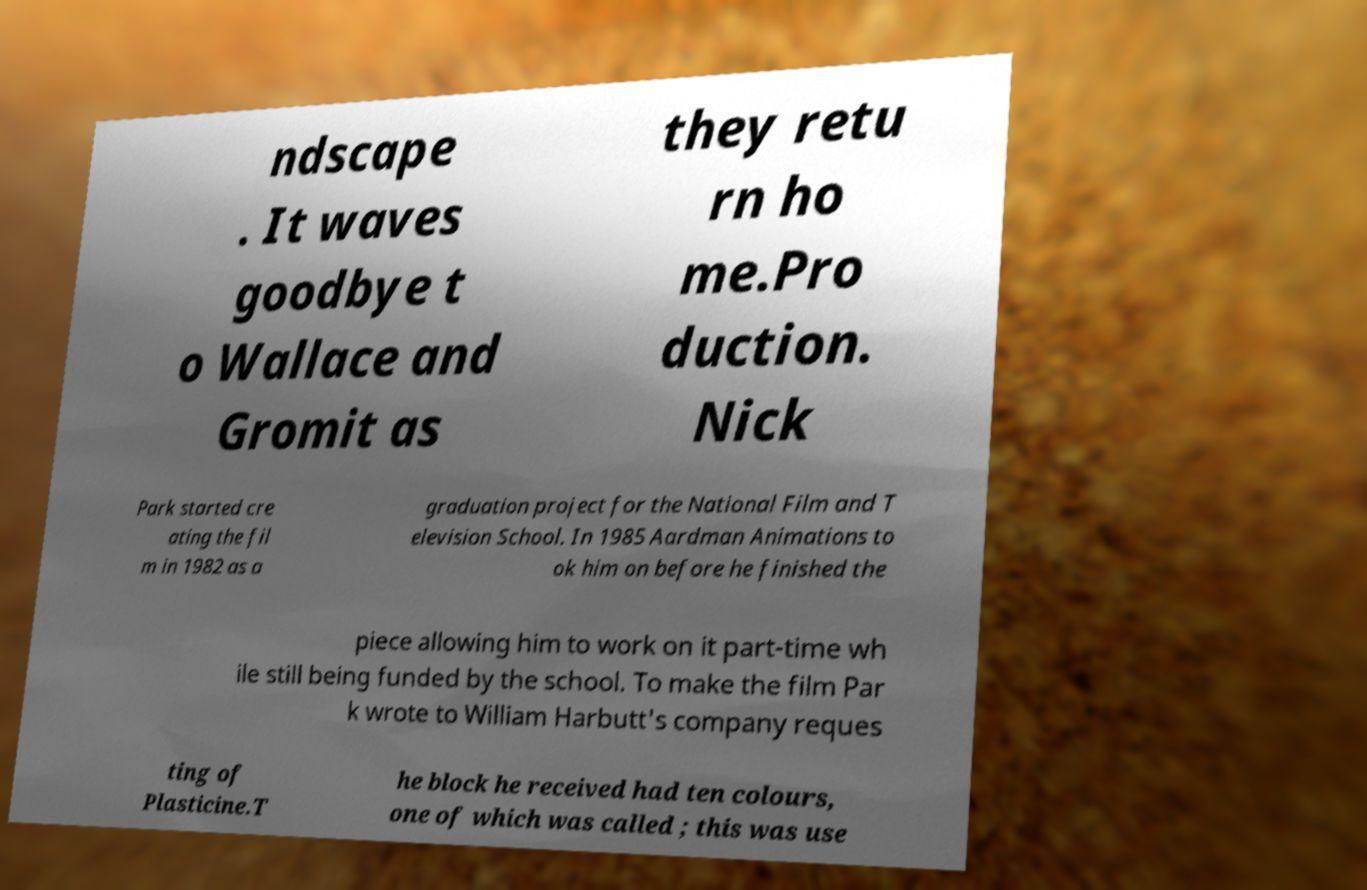Could you extract and type out the text from this image? ndscape . It waves goodbye t o Wallace and Gromit as they retu rn ho me.Pro duction. Nick Park started cre ating the fil m in 1982 as a graduation project for the National Film and T elevision School. In 1985 Aardman Animations to ok him on before he finished the piece allowing him to work on it part-time wh ile still being funded by the school. To make the film Par k wrote to William Harbutt's company reques ting of Plasticine.T he block he received had ten colours, one of which was called ; this was use 